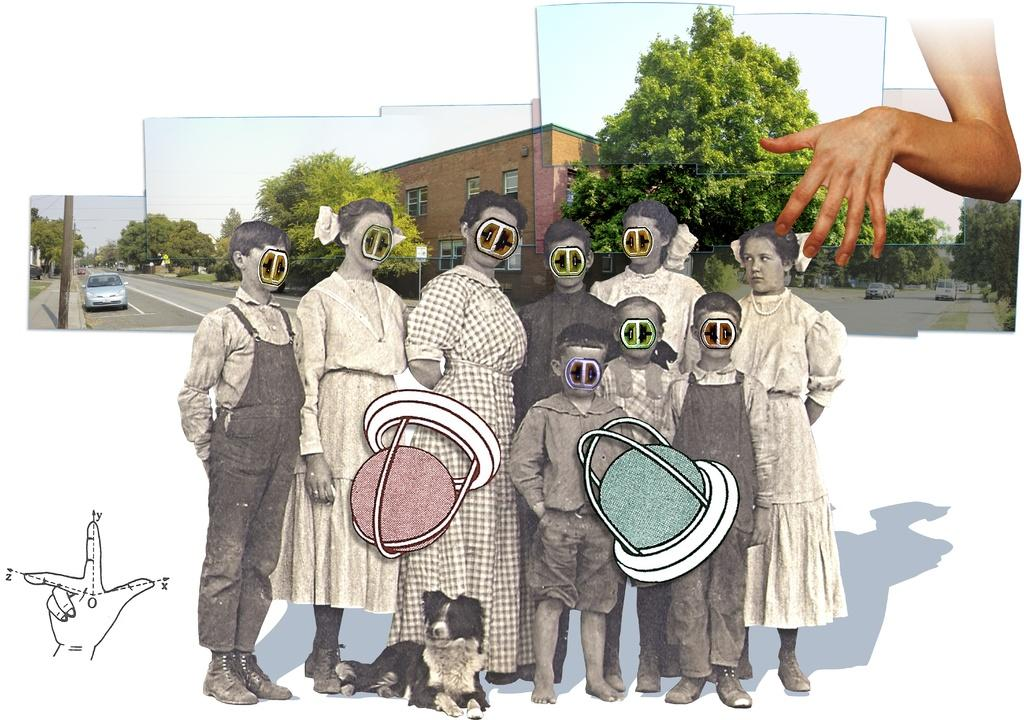What type of editing has been done to the image? The image is edited, with morphed images of people. What can be seen in the background of the image? There are pictures of trees and houses in the background. Where is the hand located in the image? The hand is on the right side of the image. What type of quince is being held by the person in the image? There is no quince present in the image; it features morphed images of people. What is the queen doing in the image? There is no queen present in the image; it features morphed images of people. 